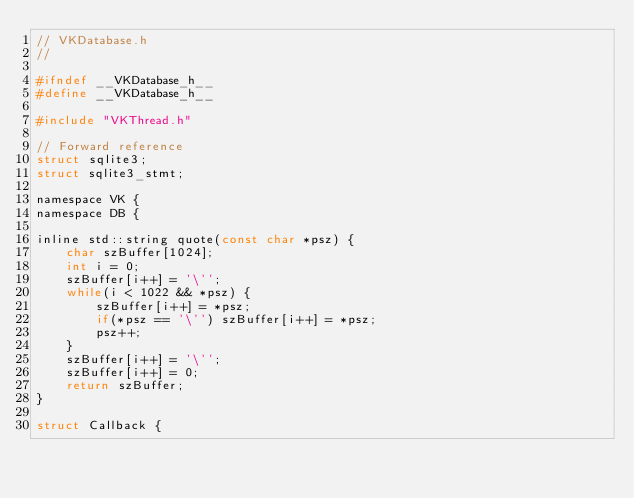<code> <loc_0><loc_0><loc_500><loc_500><_C_>// VKDatabase.h
//

#ifndef __VKDatabase_h__
#define __VKDatabase_h__

#include "VKThread.h"

// Forward reference
struct sqlite3;
struct sqlite3_stmt;

namespace VK {
namespace DB {

inline std::string quote(const char *psz) {
	char szBuffer[1024];
	int i = 0;
	szBuffer[i++] = '\'';
	while(i < 1022 && *psz) {
		szBuffer[i++] = *psz;
		if(*psz == '\'') szBuffer[i++] = *psz;
		psz++;
	}
	szBuffer[i++] = '\'';
	szBuffer[i++] = 0;
	return szBuffer;
}

struct Callback {</code> 